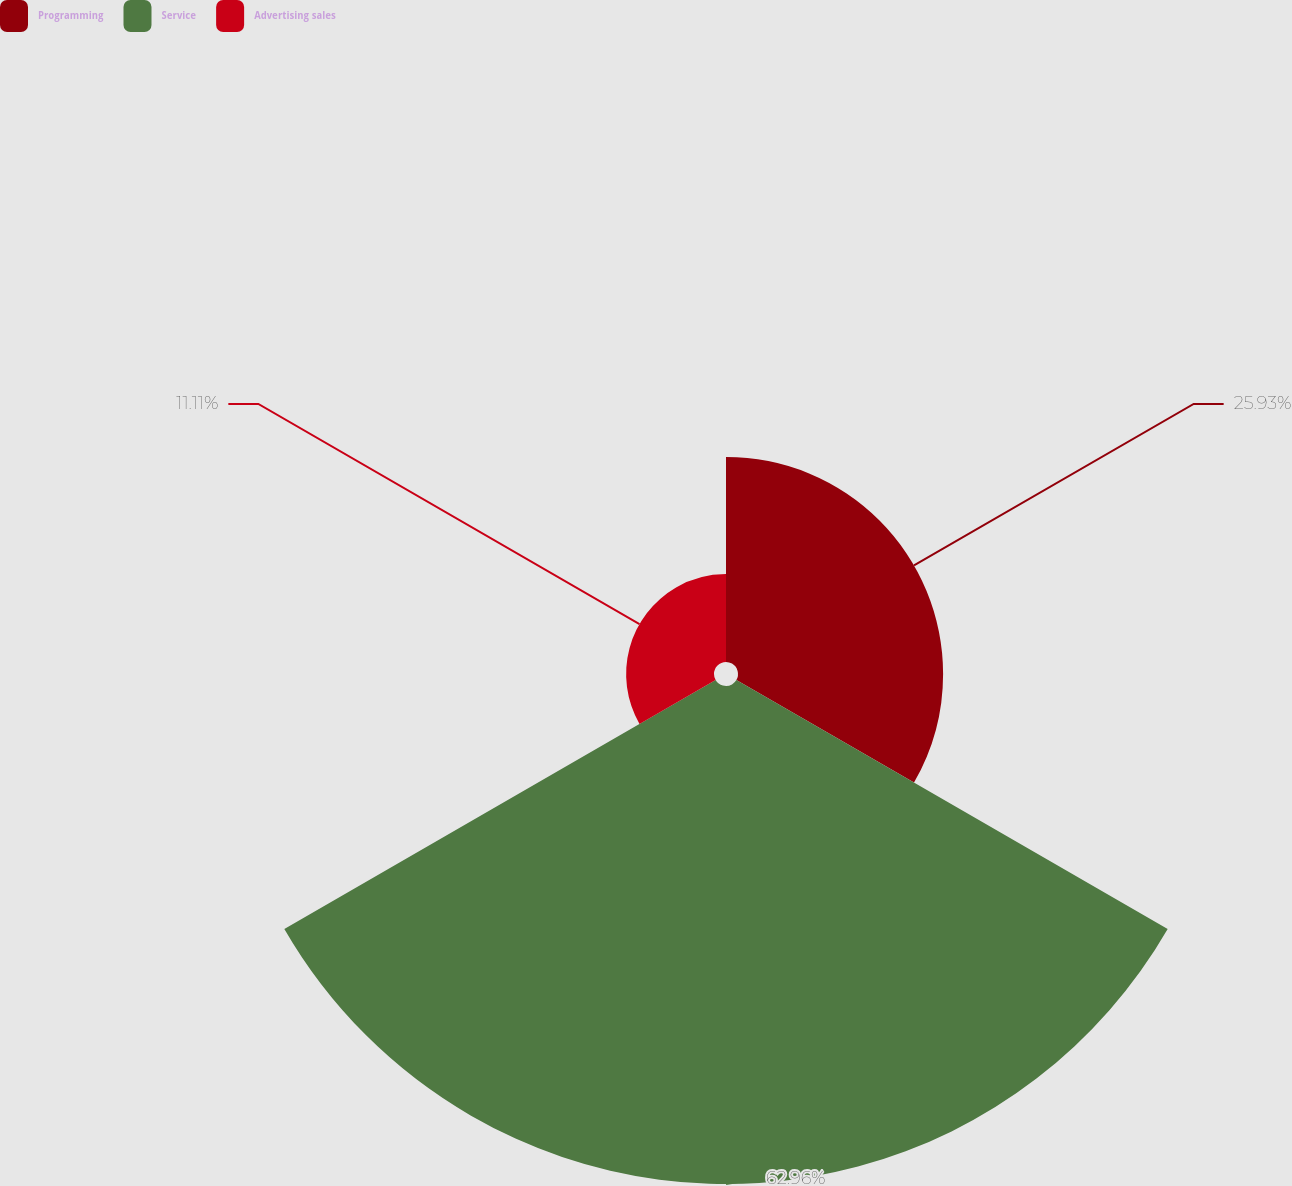Convert chart. <chart><loc_0><loc_0><loc_500><loc_500><pie_chart><fcel>Programming<fcel>Service<fcel>Advertising sales<nl><fcel>25.93%<fcel>62.96%<fcel>11.11%<nl></chart> 